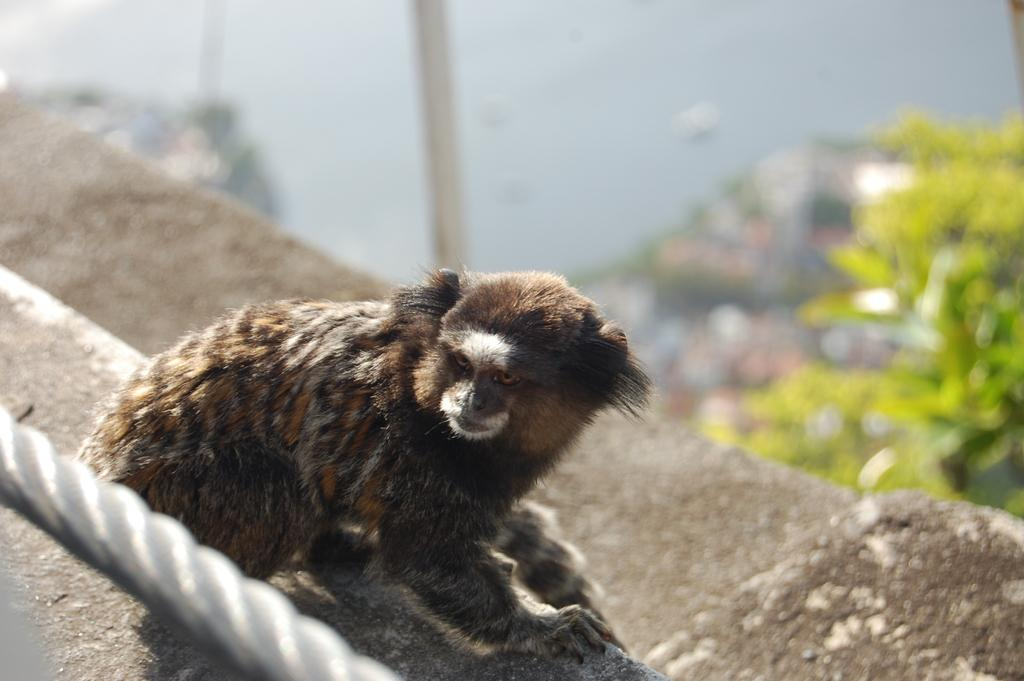What is the main subject in the center of the image? There is an animal in the center of the image. What object can be seen in the image? There is a rope in the image. What architectural feature is present in the image? There is a staircase in the image. What can be seen in the background of the image? There is a wall, a pole, and plants in the background of the image. What type of bean is being used as a channel in the image? There is no bean or channel present in the image. 